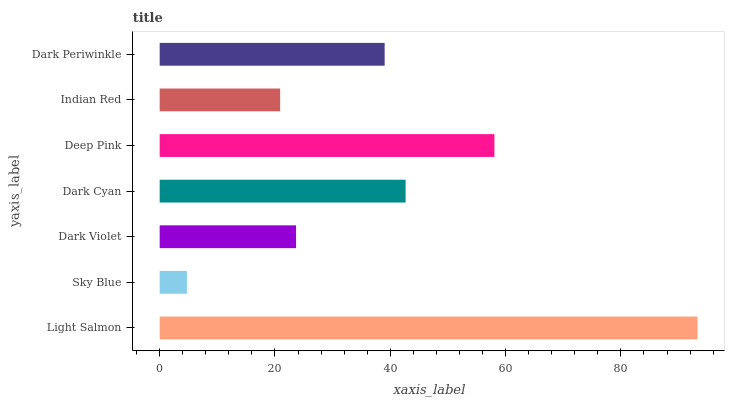Is Sky Blue the minimum?
Answer yes or no. Yes. Is Light Salmon the maximum?
Answer yes or no. Yes. Is Dark Violet the minimum?
Answer yes or no. No. Is Dark Violet the maximum?
Answer yes or no. No. Is Dark Violet greater than Sky Blue?
Answer yes or no. Yes. Is Sky Blue less than Dark Violet?
Answer yes or no. Yes. Is Sky Blue greater than Dark Violet?
Answer yes or no. No. Is Dark Violet less than Sky Blue?
Answer yes or no. No. Is Dark Periwinkle the high median?
Answer yes or no. Yes. Is Dark Periwinkle the low median?
Answer yes or no. Yes. Is Dark Violet the high median?
Answer yes or no. No. Is Deep Pink the low median?
Answer yes or no. No. 